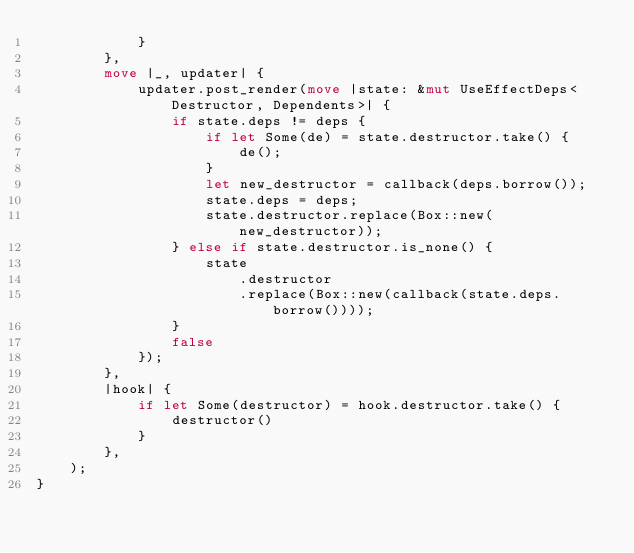Convert code to text. <code><loc_0><loc_0><loc_500><loc_500><_Rust_>            }
        },
        move |_, updater| {
            updater.post_render(move |state: &mut UseEffectDeps<Destructor, Dependents>| {
                if state.deps != deps {
                    if let Some(de) = state.destructor.take() {
                        de();
                    }
                    let new_destructor = callback(deps.borrow());
                    state.deps = deps;
                    state.destructor.replace(Box::new(new_destructor));
                } else if state.destructor.is_none() {
                    state
                        .destructor
                        .replace(Box::new(callback(state.deps.borrow())));
                }
                false
            });
        },
        |hook| {
            if let Some(destructor) = hook.destructor.take() {
                destructor()
            }
        },
    );
}
</code> 